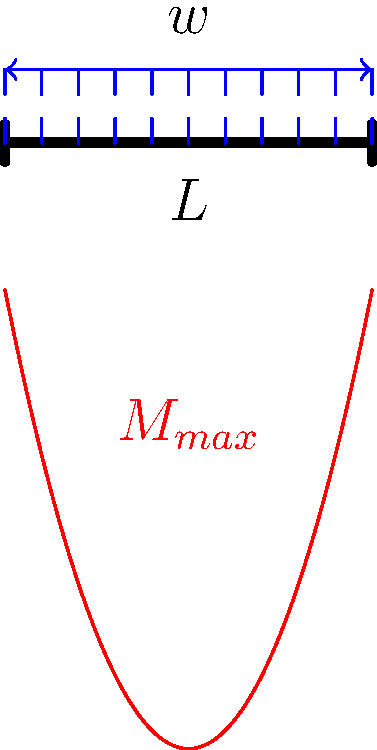In a simply supported bridge beam of length $L$ subjected to a uniformly distributed load $w$, what is the maximum bending moment $M_{max}$ and where does it occur? How might this stress distribution impact the long-term structural integrity of the bridge, considering potential cancer-causing factors in construction materials? To solve this problem, we'll follow these steps:

1. Understand the beam configuration:
   - Simply supported beam of length $L$
   - Uniformly distributed load $w$ along the entire length

2. Determine the reaction forces:
   Due to symmetry, each support bears half the total load.
   $R_A = R_B = \frac{wL}{2}$

3. Calculate the bending moment equation:
   $M(x) = R_A \cdot x - w \cdot x \cdot \frac{x}{2}$
   $M(x) = \frac{wL}{2} \cdot x - \frac{wx^2}{2}$

4. Find the maximum bending moment:
   The maximum occurs at the point where $\frac{dM}{dx} = 0$
   $\frac{dM}{dx} = \frac{wL}{2} - wx = 0$
   Solving this: $x = \frac{L}{2}$

5. Calculate the maximum bending moment:
   $M_{max} = M(\frac{L}{2}) = \frac{wL}{2} \cdot \frac{L}{2} - \frac{w(\frac{L}{2})^2}{2}$
   $M_{max} = \frac{wL^2}{8}$

6. Consider the impact on long-term structural integrity:
   - The maximum stress occurs at the midspan of the beam.
   - This stress concentration could lead to fatigue over time.
   - Some construction materials may contain potentially carcinogenic substances (e.g., certain types of preservatives or coatings).
   - Constant stress could potentially lead to micro-cracks, which might increase the release of these substances.
   - Regular inspections and maintenance are crucial to prevent any health risks associated with material degradation.
Answer: $M_{max} = \frac{wL^2}{8}$ at midspan; stress concentration may accelerate material degradation, potentially increasing exposure to harmful substances. 